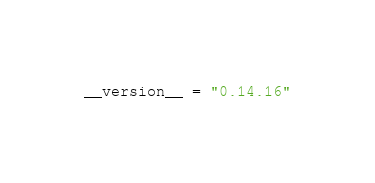Convert code to text. <code><loc_0><loc_0><loc_500><loc_500><_Python_>__version__ = "0.14.16"
</code> 